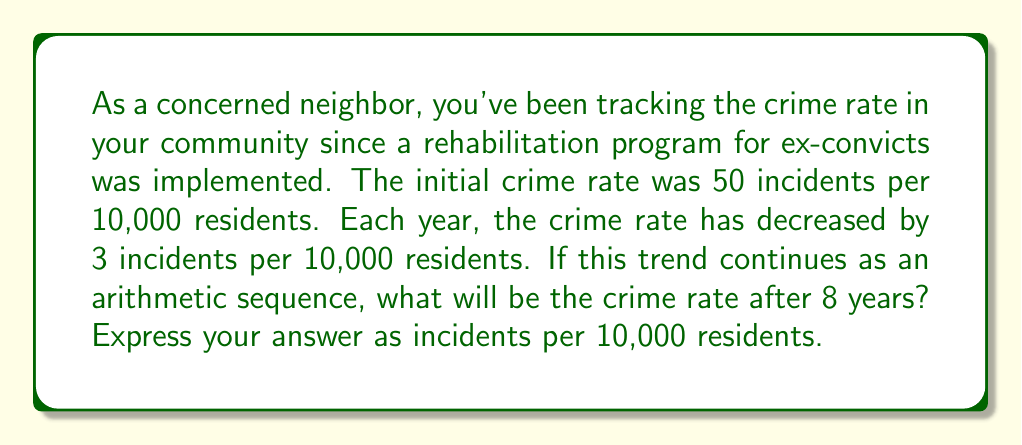What is the answer to this math problem? Let's approach this step-by-step using the properties of arithmetic sequences:

1) In an arithmetic sequence, the difference between each term is constant. Here, the common difference is -3 (a decrease of 3 incidents per 10,000 residents each year).

2) We can represent this sequence as:
   $$a_n = a_1 + (n-1)d$$
   Where:
   $a_n$ is the nth term (crime rate after n years)
   $a_1$ is the first term (initial crime rate)
   $n$ is the number of terms (years + 1)
   $d$ is the common difference

3) We're given:
   $a_1 = 50$ (initial crime rate)
   $d = -3$ (yearly decrease)
   $n = 9$ (we want the 9th term, as it represents 8 years after the initial year)

4) Substituting these values into our formula:
   $$a_9 = 50 + (9-1)(-3)$$
   $$a_9 = 50 + (-24)$$
   $$a_9 = 26$$

Thus, after 8 years, the crime rate will be 26 incidents per 10,000 residents.
Answer: 26 incidents per 10,000 residents 